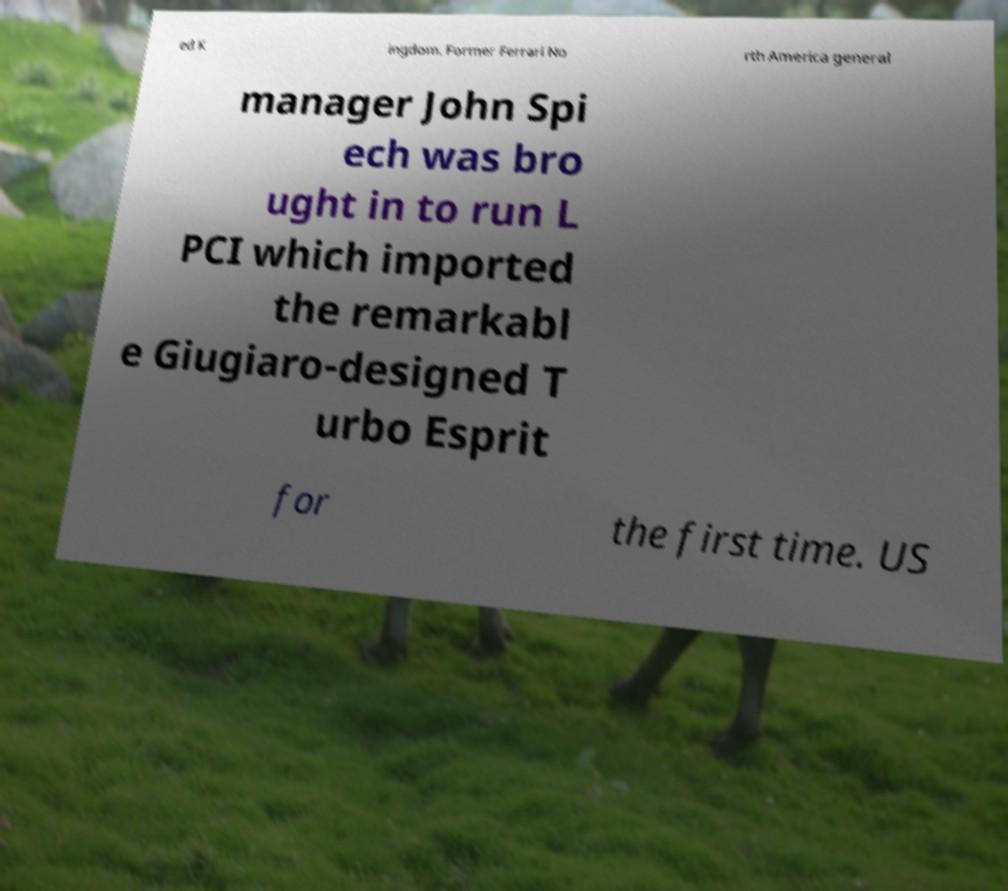Please read and relay the text visible in this image. What does it say? ed K ingdom. Former Ferrari No rth America general manager John Spi ech was bro ught in to run L PCI which imported the remarkabl e Giugiaro-designed T urbo Esprit for the first time. US 